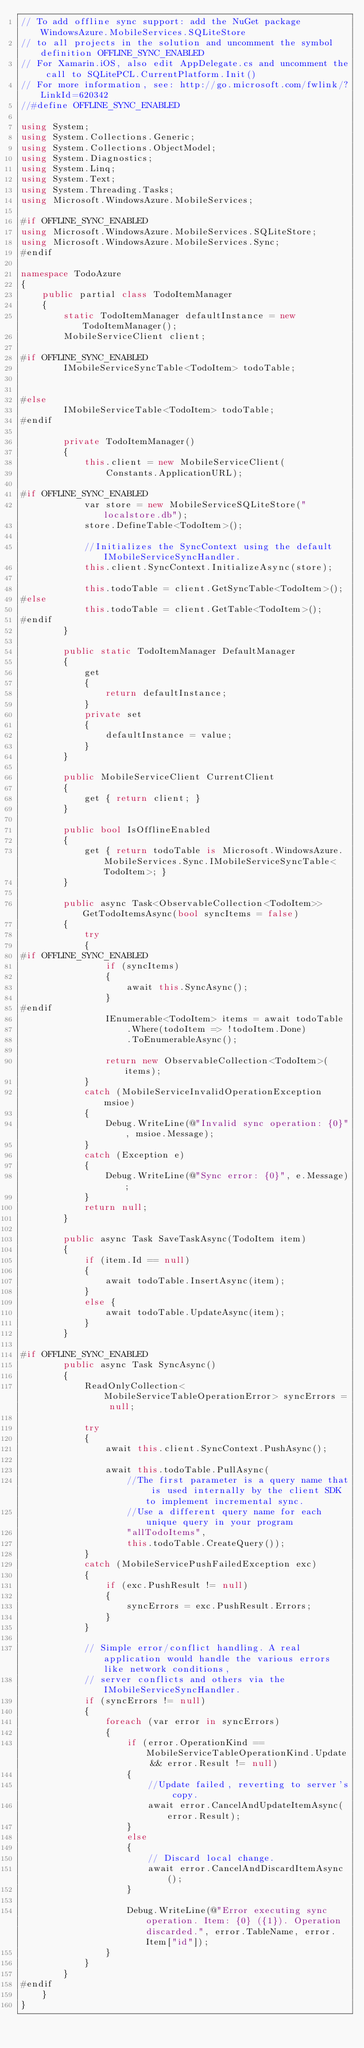Convert code to text. <code><loc_0><loc_0><loc_500><loc_500><_C#_>// To add offline sync support: add the NuGet package WindowsAzure.MobileServices.SQLiteStore
// to all projects in the solution and uncomment the symbol definition OFFLINE_SYNC_ENABLED
// For Xamarin.iOS, also edit AppDelegate.cs and uncomment the call to SQLitePCL.CurrentPlatform.Init()
// For more information, see: http://go.microsoft.com/fwlink/?LinkId=620342 
//#define OFFLINE_SYNC_ENABLED

using System;
using System.Collections.Generic;
using System.Collections.ObjectModel;
using System.Diagnostics;
using System.Linq;
using System.Text;
using System.Threading.Tasks;
using Microsoft.WindowsAzure.MobileServices;

#if OFFLINE_SYNC_ENABLED
using Microsoft.WindowsAzure.MobileServices.SQLiteStore;
using Microsoft.WindowsAzure.MobileServices.Sync;
#endif

namespace TodoAzure
{
	public partial class TodoItemManager
	{
		static TodoItemManager defaultInstance = new TodoItemManager();
		MobileServiceClient client;

#if OFFLINE_SYNC_ENABLED
        IMobileServiceSyncTable<TodoItem> todoTable;


#else
		IMobileServiceTable<TodoItem> todoTable;
#endif

		private TodoItemManager()
		{
			this.client = new MobileServiceClient(
				Constants.ApplicationURL);

#if OFFLINE_SYNC_ENABLED
            var store = new MobileServiceSQLiteStore("localstore.db");
            store.DefineTable<TodoItem>();

            //Initializes the SyncContext using the default IMobileServiceSyncHandler.
            this.client.SyncContext.InitializeAsync(store);

            this.todoTable = client.GetSyncTable<TodoItem>();
#else
			this.todoTable = client.GetTable<TodoItem>();
#endif
		}

		public static TodoItemManager DefaultManager
		{
			get
			{
				return defaultInstance;
			}
			private set
			{
				defaultInstance = value;
			}
		}

		public MobileServiceClient CurrentClient
		{
			get { return client; }
		}

		public bool IsOfflineEnabled
		{
			get { return todoTable is Microsoft.WindowsAzure.MobileServices.Sync.IMobileServiceSyncTable<TodoItem>; }
		}

		public async Task<ObservableCollection<TodoItem>> GetTodoItemsAsync(bool syncItems = false)
		{
			try
			{
#if OFFLINE_SYNC_ENABLED
                if (syncItems)
                {
                    await this.SyncAsync();
                }
#endif
				IEnumerable<TodoItem> items = await todoTable
					.Where(todoItem => !todoItem.Done)
					.ToEnumerableAsync();

				return new ObservableCollection<TodoItem>(items);
			}
			catch (MobileServiceInvalidOperationException msioe)
			{
				Debug.WriteLine(@"Invalid sync operation: {0}", msioe.Message);
			}
			catch (Exception e)
			{
				Debug.WriteLine(@"Sync error: {0}", e.Message);
			}
			return null;
		}

		public async Task SaveTaskAsync(TodoItem item)
		{
			if (item.Id == null)
			{
				await todoTable.InsertAsync(item);
			}
			else {
				await todoTable.UpdateAsync(item);
			}
		}

#if OFFLINE_SYNC_ENABLED
        public async Task SyncAsync()
        {
            ReadOnlyCollection<MobileServiceTableOperationError> syncErrors = null;

            try
            {
                await this.client.SyncContext.PushAsync();

                await this.todoTable.PullAsync(
                    //The first parameter is a query name that is used internally by the client SDK to implement incremental sync.
                    //Use a different query name for each unique query in your program
                    "allTodoItems",
                    this.todoTable.CreateQuery());
            }
            catch (MobileServicePushFailedException exc)
            {
                if (exc.PushResult != null)
                {
                    syncErrors = exc.PushResult.Errors;
                }
            }

            // Simple error/conflict handling. A real application would handle the various errors like network conditions,
            // server conflicts and others via the IMobileServiceSyncHandler.
            if (syncErrors != null)
            {
                foreach (var error in syncErrors)
                {
                    if (error.OperationKind == MobileServiceTableOperationKind.Update && error.Result != null)
                    {
                        //Update failed, reverting to server's copy.
                        await error.CancelAndUpdateItemAsync(error.Result);
                    }
                    else
                    {
                        // Discard local change.
                        await error.CancelAndDiscardItemAsync();
                    }

                    Debug.WriteLine(@"Error executing sync operation. Item: {0} ({1}). Operation discarded.", error.TableName, error.Item["id"]);
                }
            }
        }
#endif
	}
}
</code> 